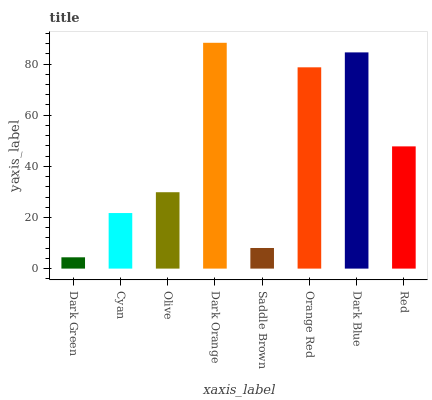Is Dark Green the minimum?
Answer yes or no. Yes. Is Dark Orange the maximum?
Answer yes or no. Yes. Is Cyan the minimum?
Answer yes or no. No. Is Cyan the maximum?
Answer yes or no. No. Is Cyan greater than Dark Green?
Answer yes or no. Yes. Is Dark Green less than Cyan?
Answer yes or no. Yes. Is Dark Green greater than Cyan?
Answer yes or no. No. Is Cyan less than Dark Green?
Answer yes or no. No. Is Red the high median?
Answer yes or no. Yes. Is Olive the low median?
Answer yes or no. Yes. Is Dark Green the high median?
Answer yes or no. No. Is Cyan the low median?
Answer yes or no. No. 